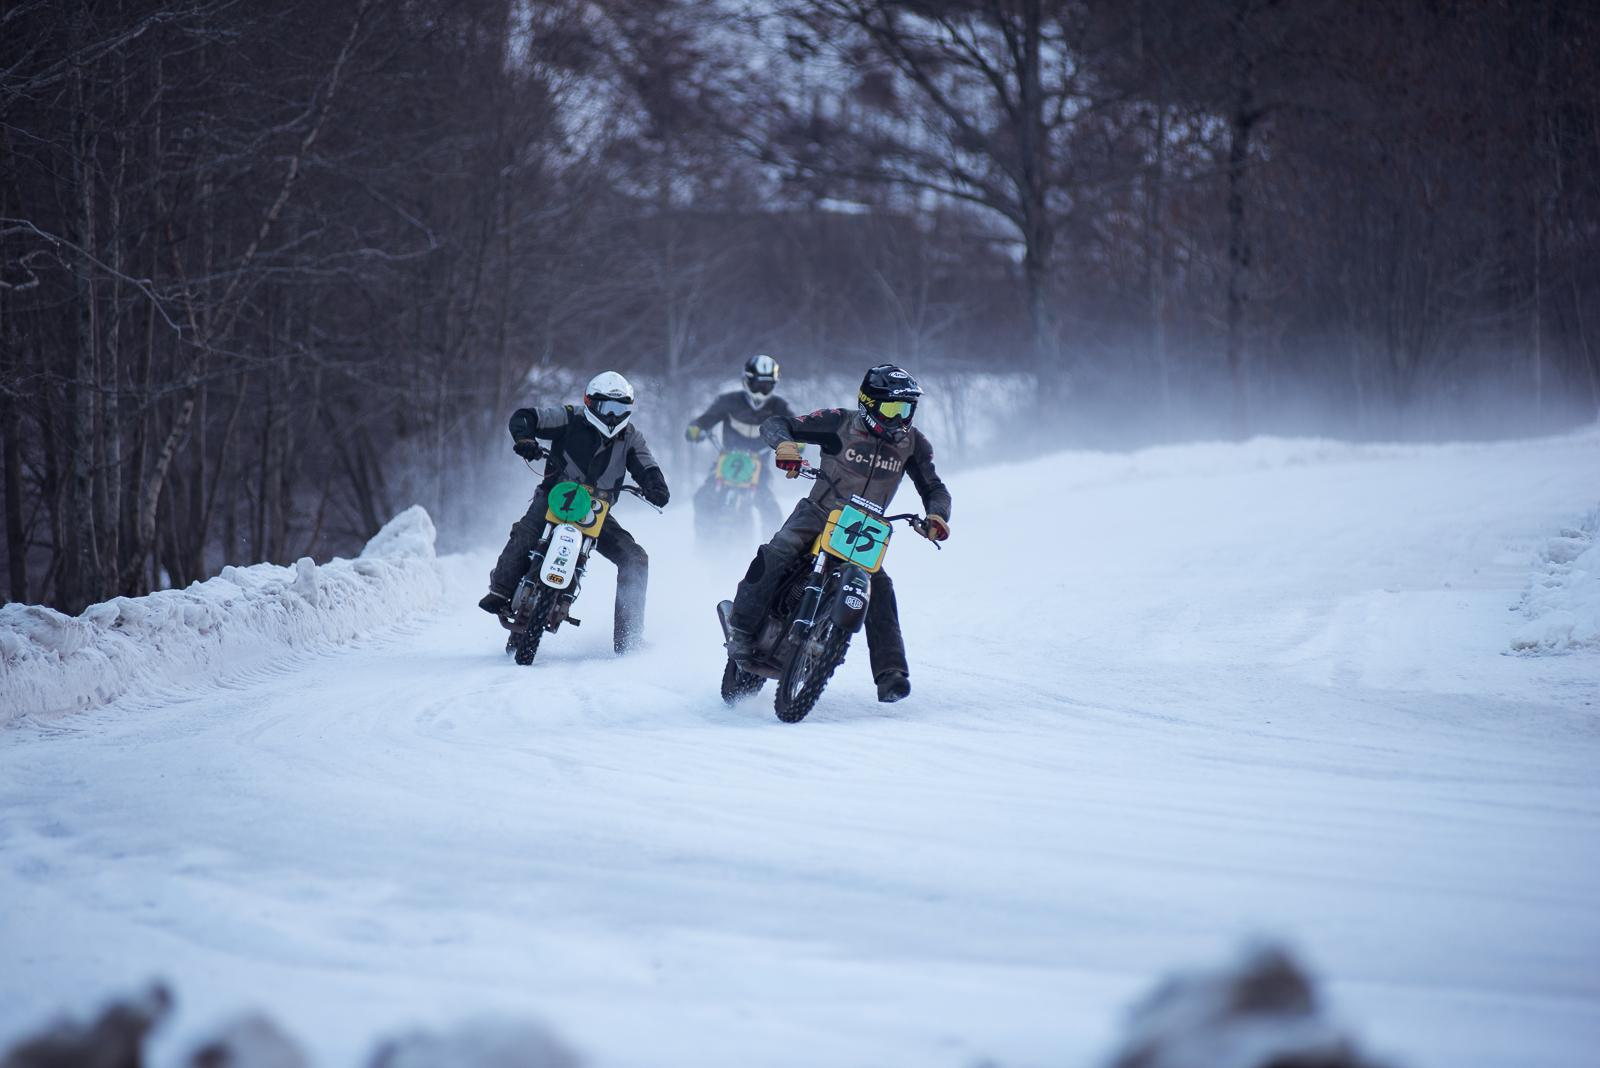Can you tell me more about the setting of this event? The image shows a group of motorbike riders on what appears to be a snow-covered track, surrounded by a leafless forest, indicative of a winter motorsport event possibly held in a colder climate or during the winter season. 